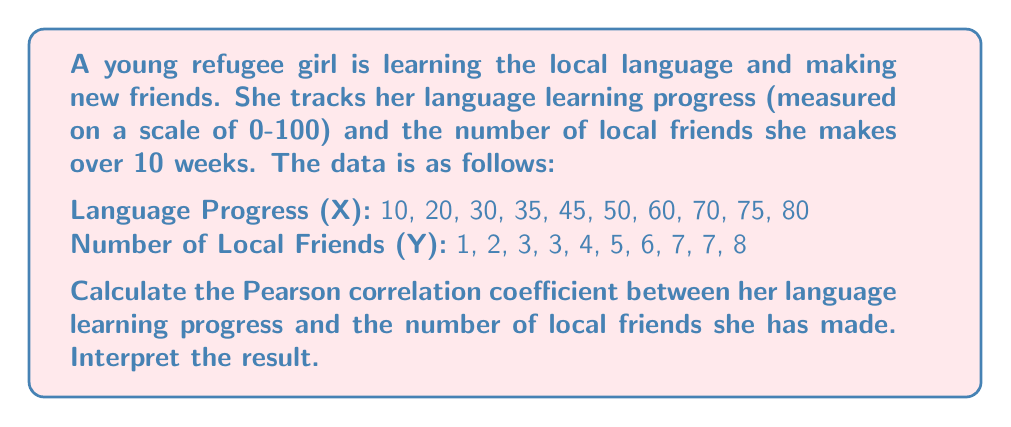Give your solution to this math problem. To calculate the Pearson correlation coefficient, we'll use the formula:

$$ r = \frac{\sum_{i=1}^{n} (x_i - \bar{x})(y_i - \bar{y})}{\sqrt{\sum_{i=1}^{n} (x_i - \bar{x})^2 \sum_{i=1}^{n} (y_i - \bar{y})^2}} $$

Where:
$x_i$ and $y_i$ are the individual sample points
$\bar{x}$ and $\bar{y}$ are the sample means

Step 1: Calculate the means
$\bar{x} = \frac{10 + 20 + 30 + 35 + 45 + 50 + 60 + 70 + 75 + 80}{10} = 47.5$
$\bar{y} = \frac{1 + 2 + 3 + 3 + 4 + 5 + 6 + 7 + 7 + 8}{10} = 4.6$

Step 2: Calculate $(x_i - \bar{x})$, $(y_i - \bar{y})$, $(x_i - \bar{x})^2$, $(y_i - \bar{y})^2$, and $(x_i - \bar{x})(y_i - \bar{y})$ for each data point.

Step 3: Sum up the values from Step 2
$\sum (x_i - \bar{x})(y_i - \bar{y}) = 1023.5$
$\sum (x_i - \bar{x})^2 = 6562.5$
$\sum (y_i - \bar{y})^2 = 46.4$

Step 4: Apply the formula
$$ r = \frac{1023.5}{\sqrt{6562.5 \times 46.4}} = \frac{1023.5}{551.82} = 0.9847 $$

Interpretation: The Pearson correlation coefficient of 0.9847 indicates a very strong positive correlation between the girl's language learning progress and the number of local friends she has made. As her language skills improve, she tends to make more local friends, or vice versa.
Answer: The Pearson correlation coefficient is 0.9847, indicating a very strong positive correlation between language learning progress and number of local friends made. 